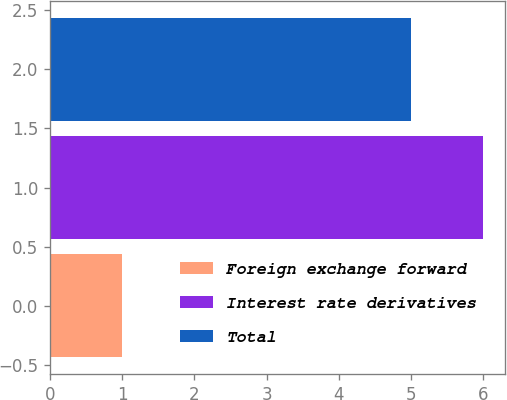Convert chart to OTSL. <chart><loc_0><loc_0><loc_500><loc_500><bar_chart><fcel>Foreign exchange forward<fcel>Interest rate derivatives<fcel>Total<nl><fcel>1<fcel>6<fcel>5<nl></chart> 